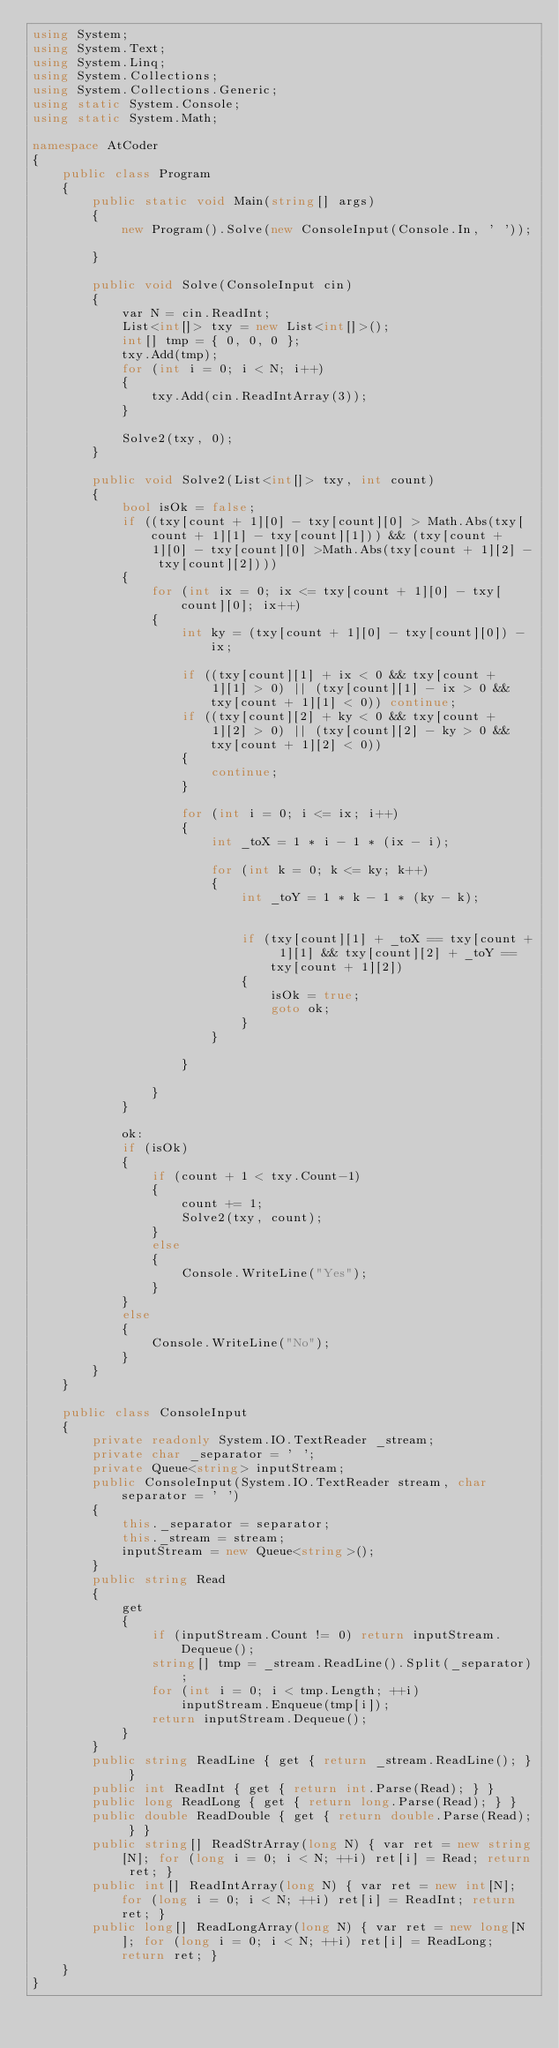Convert code to text. <code><loc_0><loc_0><loc_500><loc_500><_C#_>using System;
using System.Text;
using System.Linq;
using System.Collections;
using System.Collections.Generic;
using static System.Console;
using static System.Math;

namespace AtCoder
{
    public class Program
    {
        public static void Main(string[] args)
        {
            new Program().Solve(new ConsoleInput(Console.In, ' '));

        }

        public void Solve(ConsoleInput cin)
        {
            var N = cin.ReadInt;
            List<int[]> txy = new List<int[]>();
            int[] tmp = { 0, 0, 0 };
            txy.Add(tmp);
            for (int i = 0; i < N; i++)
            {
                txy.Add(cin.ReadIntArray(3));
            }

            Solve2(txy, 0);
        }

        public void Solve2(List<int[]> txy, int count)
        {
            bool isOk = false;
            if ((txy[count + 1][0] - txy[count][0] > Math.Abs(txy[count + 1][1] - txy[count][1])) && (txy[count + 1][0] - txy[count][0] >Math.Abs(txy[count + 1][2] - txy[count][2])))
            {
                for (int ix = 0; ix <= txy[count + 1][0] - txy[count][0]; ix++)
                {
                    int ky = (txy[count + 1][0] - txy[count][0]) - ix;

                    if ((txy[count][1] + ix < 0 && txy[count + 1][1] > 0) || (txy[count][1] - ix > 0 && txy[count + 1][1] < 0)) continue;
                    if ((txy[count][2] + ky < 0 && txy[count + 1][2] > 0) || (txy[count][2] - ky > 0 && txy[count + 1][2] < 0))
                    {
                        continue;
                    }

                    for (int i = 0; i <= ix; i++)
                    {
                        int _toX = 1 * i - 1 * (ix - i);

                        for (int k = 0; k <= ky; k++)
                        {
                            int _toY = 1 * k - 1 * (ky - k);


                            if (txy[count][1] + _toX == txy[count + 1][1] && txy[count][2] + _toY == txy[count + 1][2])
                            {
                                isOk = true;
                                goto ok;
                            }
                        }

                    }

                }
            }

            ok:
            if (isOk)
            {
                if (count + 1 < txy.Count-1)
                {
                    count += 1;
                    Solve2(txy, count);
                }
                else
                {
                    Console.WriteLine("Yes");
                }
            }
            else
            {
                Console.WriteLine("No");
            }
        }
    }

    public class ConsoleInput
    {
        private readonly System.IO.TextReader _stream;
        private char _separator = ' ';
        private Queue<string> inputStream;
        public ConsoleInput(System.IO.TextReader stream, char separator = ' ')
        {
            this._separator = separator;
            this._stream = stream;
            inputStream = new Queue<string>();
        }
        public string Read
        {
            get
            {
                if (inputStream.Count != 0) return inputStream.Dequeue();
                string[] tmp = _stream.ReadLine().Split(_separator);
                for (int i = 0; i < tmp.Length; ++i)
                    inputStream.Enqueue(tmp[i]);
                return inputStream.Dequeue();
            }
        }
        public string ReadLine { get { return _stream.ReadLine(); } }
        public int ReadInt { get { return int.Parse(Read); } }
        public long ReadLong { get { return long.Parse(Read); } }
        public double ReadDouble { get { return double.Parse(Read); } }
        public string[] ReadStrArray(long N) { var ret = new string[N]; for (long i = 0; i < N; ++i) ret[i] = Read; return ret; }
        public int[] ReadIntArray(long N) { var ret = new int[N]; for (long i = 0; i < N; ++i) ret[i] = ReadInt; return ret; }
        public long[] ReadLongArray(long N) { var ret = new long[N]; for (long i = 0; i < N; ++i) ret[i] = ReadLong; return ret; }
    }
}</code> 